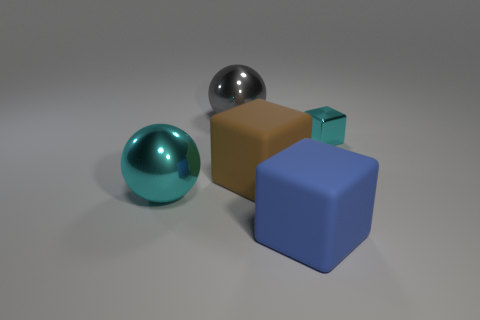How many things are either big balls or balls that are behind the large brown rubber thing?
Offer a very short reply. 2. Are there fewer gray shiny balls that are in front of the big blue rubber thing than large gray objects?
Provide a short and direct response. Yes. What is the size of the metallic thing on the right side of the big metallic thing behind the metal object that is right of the gray thing?
Your answer should be compact. Small. What color is the metal thing that is on the left side of the blue rubber object and in front of the gray metallic ball?
Your answer should be compact. Cyan. How many cyan metallic things are there?
Your answer should be very brief. 2. Is there any other thing that is the same size as the cyan sphere?
Your response must be concise. Yes. Does the cyan cube have the same material as the brown thing?
Keep it short and to the point. No. Is the size of the matte thing behind the blue object the same as the matte object that is to the right of the brown cube?
Provide a succinct answer. Yes. Are there fewer large yellow matte cylinders than big brown cubes?
Your response must be concise. Yes. How many metallic things are either brown cubes or tiny yellow cylinders?
Provide a short and direct response. 0. 